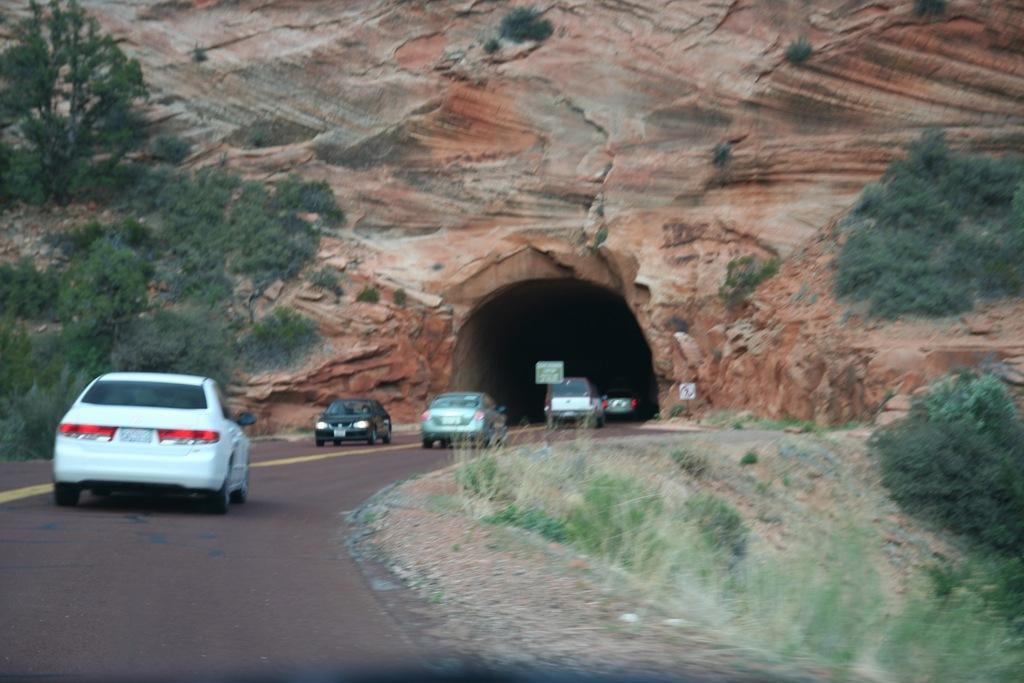Can you describe this image briefly? In this image we can see cars on the road. In the background there are trees and we can see a tunnel. 